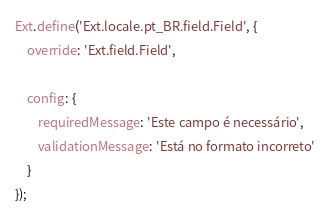Convert code to text. <code><loc_0><loc_0><loc_500><loc_500><_JavaScript_>Ext.define('Ext.locale.pt_BR.field.Field', {
    override: 'Ext.field.Field',

    config: {
        requiredMessage: 'Este campo é necessário',
        validationMessage: 'Está no formato incorreto'
    }
});</code> 